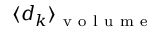<formula> <loc_0><loc_0><loc_500><loc_500>\langle d _ { k } \rangle _ { v o l u m e }</formula> 